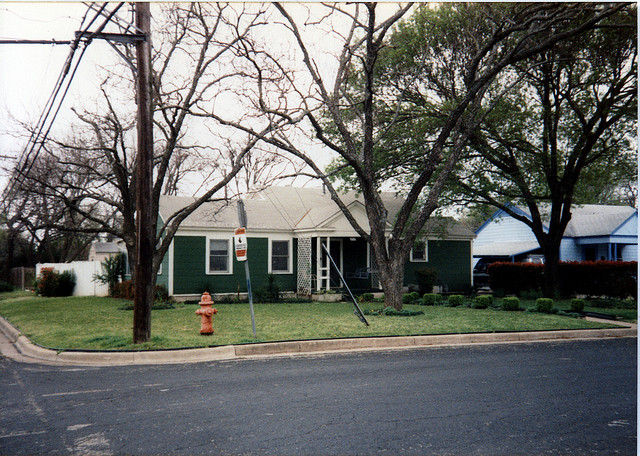How many cars are in the driveway? 0 